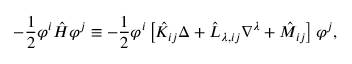<formula> <loc_0><loc_0><loc_500><loc_500>- \frac { 1 } { 2 } \varphi ^ { i } \hat { H } \varphi ^ { j } \equiv - \frac { 1 } { 2 } \varphi ^ { i } \left [ \hat { K } _ { i j } \Delta + \hat { L } _ { \lambda , i j } \nabla ^ { \lambda } + \hat { M } _ { i j } \right ] \varphi ^ { j } ,</formula> 